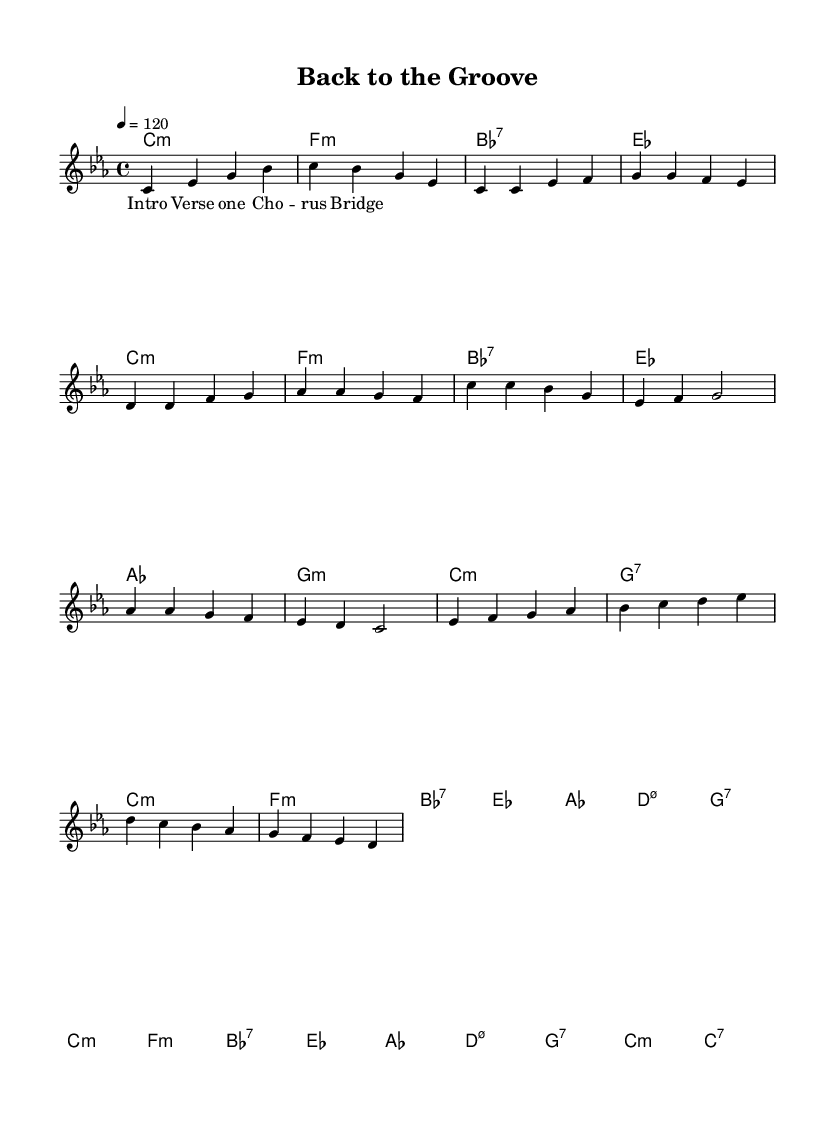What is the key signature of this music? The key signature is C minor, which has three flat notes: B flat, E flat, and A flat. You can determine this by looking at the corresponding symbols at the beginning of the staff.
Answer: C minor What is the time signature of this music? The time signature is indicated at the beginning of the sheet music as 4/4. This means there are four beats per measure and the quarter note gets one beat.
Answer: 4/4 What is the tempo marking for this piece? The tempo marking states "4 = 120," which means each quarter note is to be played at a speed of 120 beats per minute. This ensures a steady and lively pace throughout the piece.
Answer: 120 What is the chord for the first measure? The first measure contains the chord C minor, indicated by the "c1:m" marking in the chord section. The designation 'm' signifies that it is a minor chord.
Answer: C minor How many measures are there in the chorus section? The chorus section consists of four measures, which can be counted by reviewing the rhythm and the alignment of the written music during that specified section.
Answer: 4 Which vocal style is suggested by the sheet music? The sheet music contains soul-inspired vocals, which can be inferred from the phrasing and style indicated in the lyrics section where it matches with typical characteristics seen in Amy Winehouse's performances.
Answer: Soul-inspired What type of harmony is used in the bridge section? In the bridge section, the harmony uses a combination of minor and dominant seventh chords, with specific notations like "f1:m" and "g:7." This style is typical in jazz-funk fusion, highlighting the complexity of the harmonic structure.
Answer: Minor and dominant seventh 